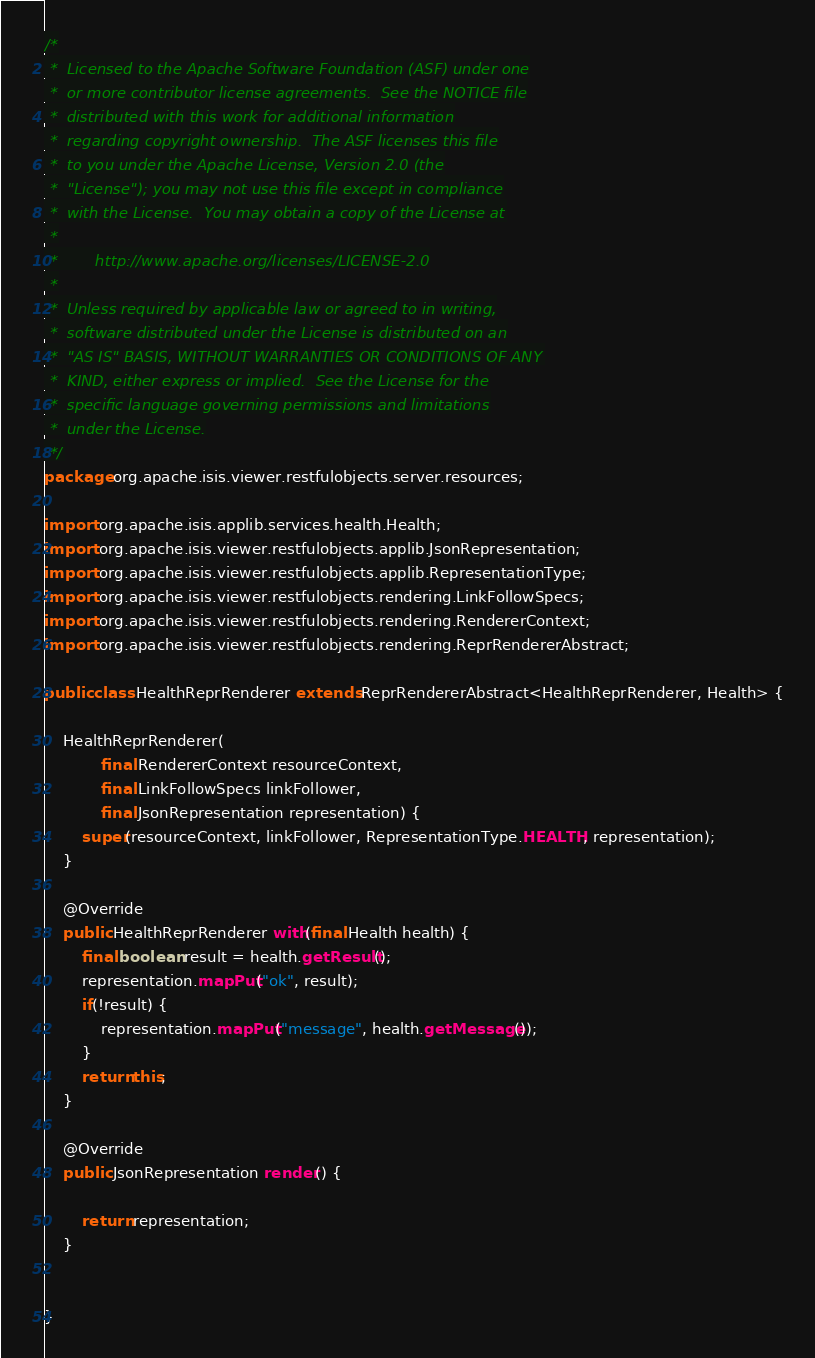<code> <loc_0><loc_0><loc_500><loc_500><_Java_>/*
 *  Licensed to the Apache Software Foundation (ASF) under one
 *  or more contributor license agreements.  See the NOTICE file
 *  distributed with this work for additional information
 *  regarding copyright ownership.  The ASF licenses this file
 *  to you under the Apache License, Version 2.0 (the
 *  "License"); you may not use this file except in compliance
 *  with the License.  You may obtain a copy of the License at
 *
 *        http://www.apache.org/licenses/LICENSE-2.0
 *
 *  Unless required by applicable law or agreed to in writing,
 *  software distributed under the License is distributed on an
 *  "AS IS" BASIS, WITHOUT WARRANTIES OR CONDITIONS OF ANY
 *  KIND, either express or implied.  See the License for the
 *  specific language governing permissions and limitations
 *  under the License.
 */
package org.apache.isis.viewer.restfulobjects.server.resources;

import org.apache.isis.applib.services.health.Health;
import org.apache.isis.viewer.restfulobjects.applib.JsonRepresentation;
import org.apache.isis.viewer.restfulobjects.applib.RepresentationType;
import org.apache.isis.viewer.restfulobjects.rendering.LinkFollowSpecs;
import org.apache.isis.viewer.restfulobjects.rendering.RendererContext;
import org.apache.isis.viewer.restfulobjects.rendering.ReprRendererAbstract;

public class HealthReprRenderer extends ReprRendererAbstract<HealthReprRenderer, Health> {

    HealthReprRenderer(
            final RendererContext resourceContext,
            final LinkFollowSpecs linkFollower,
            final JsonRepresentation representation) {
        super(resourceContext, linkFollower, RepresentationType.HEALTH, representation);
    }

    @Override
    public HealthReprRenderer with(final Health health) {
        final boolean result = health.getResult();
        representation.mapPut("ok", result);
        if(!result) {
            representation.mapPut("message", health.getMessage());
        }
        return this;
    }

    @Override
    public JsonRepresentation render() {

        return representation;
    }


}</code> 